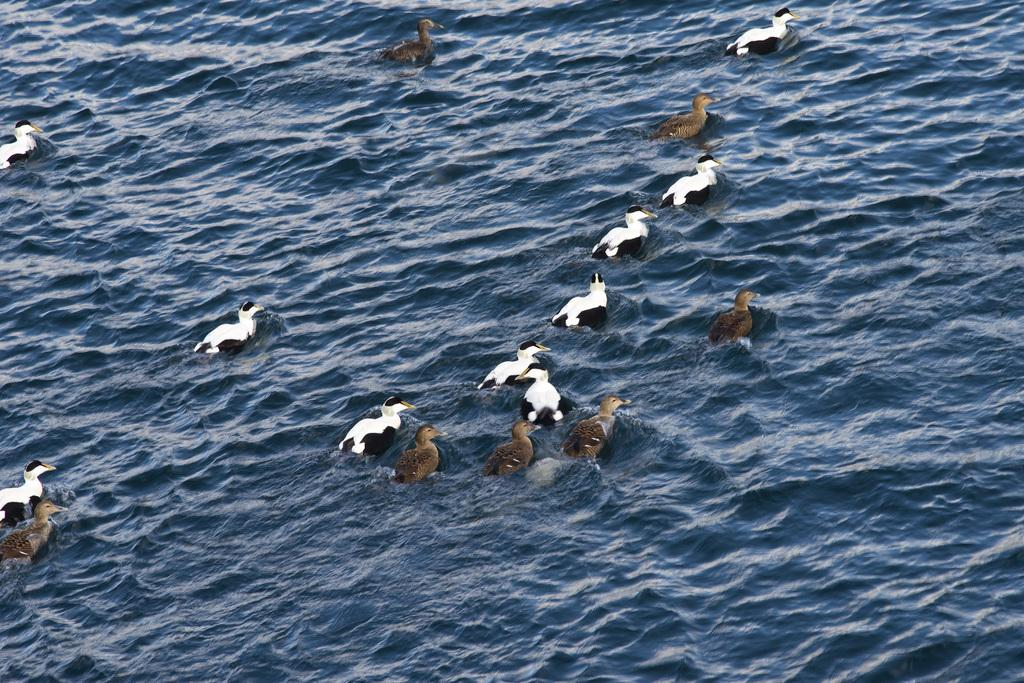Where was the image taken? The image was clicked outside the city. What can be seen in the water body in the image? There are birds in the water body in the image. What is the condition of the water in the image? There are ripples in the water body in the image. Who is the owner of the birds in the image? There is no information about the ownership of the birds in the image. 